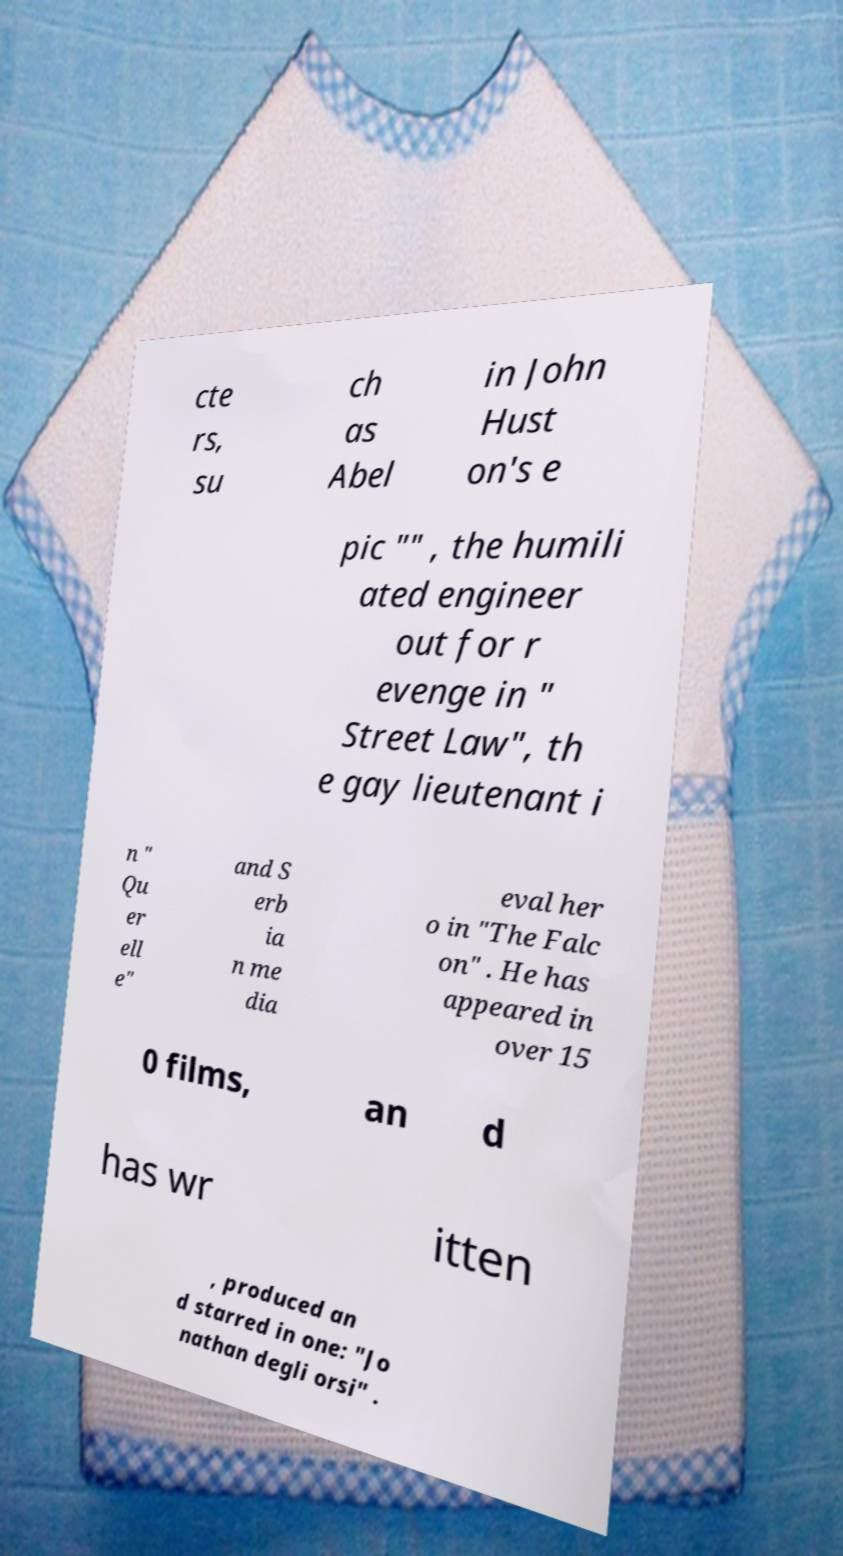What messages or text are displayed in this image? I need them in a readable, typed format. cte rs, su ch as Abel in John Hust on's e pic "" , the humili ated engineer out for r evenge in " Street Law", th e gay lieutenant i n " Qu er ell e" and S erb ia n me dia eval her o in "The Falc on" . He has appeared in over 15 0 films, an d has wr itten , produced an d starred in one: "Jo nathan degli orsi" . 